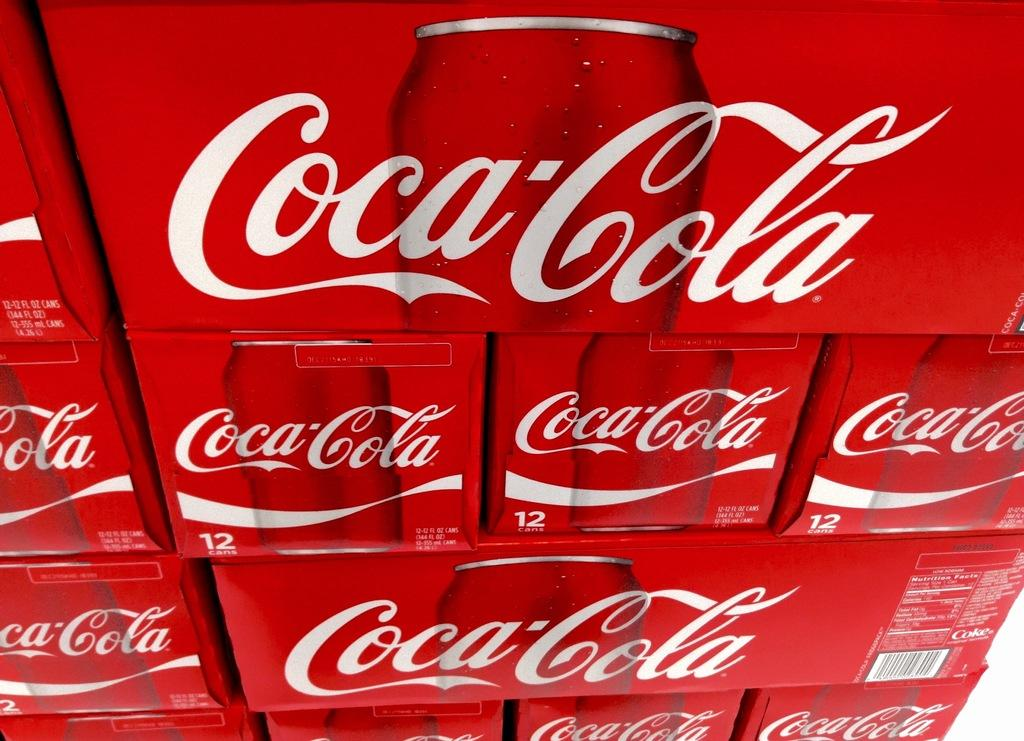What type of containers are present in the image? There are coke tin containers in the image. What type of pancake is being served on the button in the image? There is no button or pancake present in the image; it only features coke tin containers. 